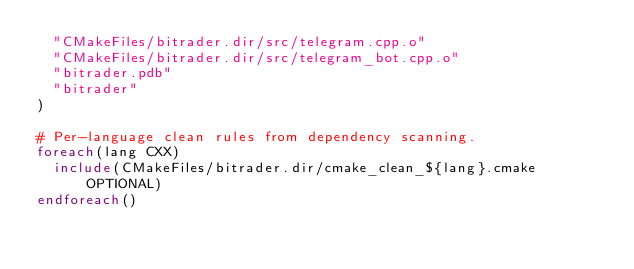Convert code to text. <code><loc_0><loc_0><loc_500><loc_500><_CMake_>  "CMakeFiles/bitrader.dir/src/telegram.cpp.o"
  "CMakeFiles/bitrader.dir/src/telegram_bot.cpp.o"
  "bitrader.pdb"
  "bitrader"
)

# Per-language clean rules from dependency scanning.
foreach(lang CXX)
  include(CMakeFiles/bitrader.dir/cmake_clean_${lang}.cmake OPTIONAL)
endforeach()
</code> 